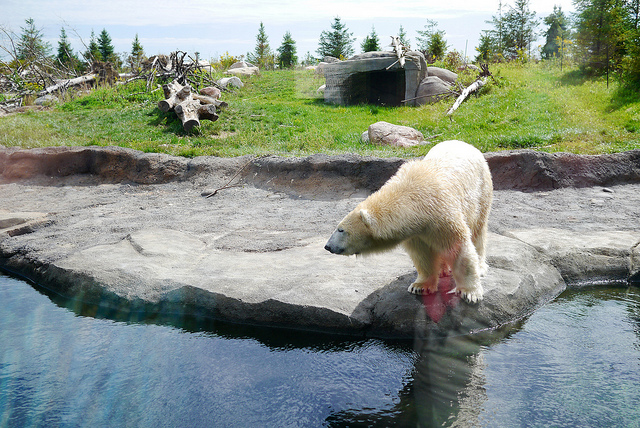Can you tell me about the habitat in which this polar bear is living? Based on the image, the polar bear seems to be in a man-made habitat designed to resemble the arctic environment. It has elements like rocks, a water body, and some grassy areas, characteristic of polar bear enclosures in zoos.  Is this habitat ideal for a polar bear? While the habitat in the image attempts to mimic natural conditions, it's not as vast nor as diverse as a polar bear's natural arctic environment. Zoos strive to improve these enclosures, but true wild spaces offer more room for roaming and hunting behaviors that are essential for a polar bear's physical and mental health. 